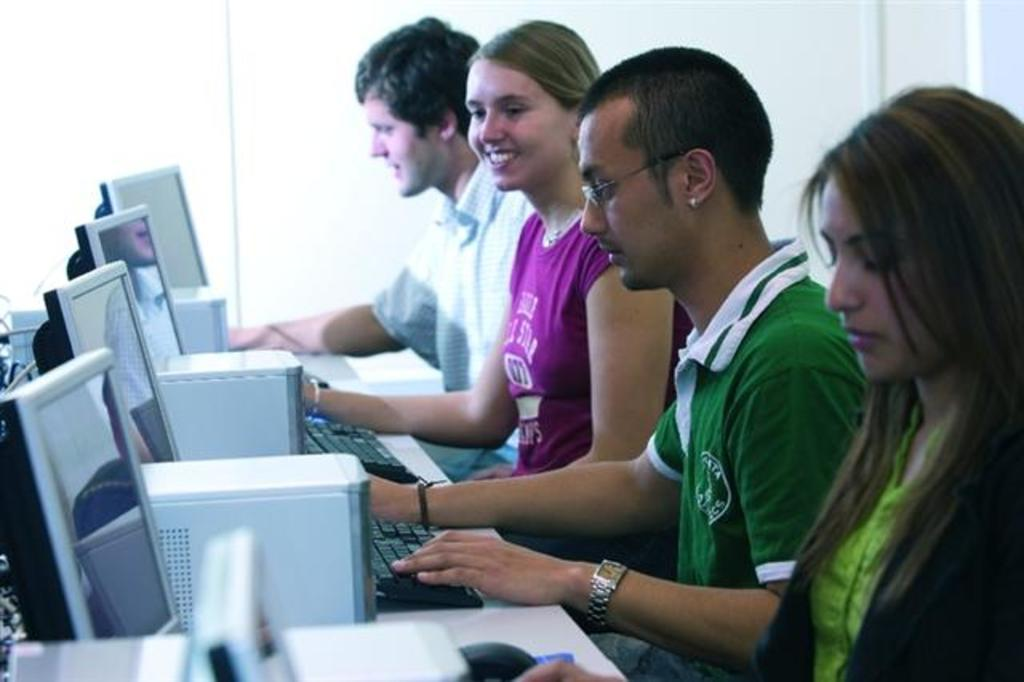How many people are sitting in the image? There are four persons sitting in the image. What type of equipment can be seen in the image? Monitors, PC desktops, keyboards, and a mouse are visible in the image. What is supporting the equipment in the image? The table is present in the image. What is the color of the background in the image? The background of the image is white. What type of flag is being waved by the person in the image? There is no flag present in the image; it features four people sitting at a table with computer equipment. Can you see any feathers on the keyboards in the image? There are no feathers visible on the keyboards in the image. 